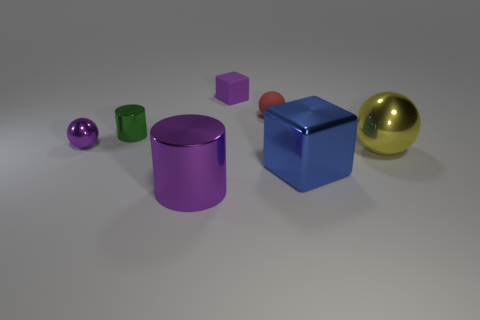How big is the blue cube?
Ensure brevity in your answer.  Large. There is a cube to the right of the small purple rubber thing; what is its size?
Provide a succinct answer. Large. What shape is the thing that is both left of the tiny purple cube and in front of the tiny purple metallic thing?
Offer a very short reply. Cylinder. What number of other things are the same shape as the large blue metal object?
Your answer should be compact. 1. What is the color of the metallic sphere that is the same size as the red matte thing?
Offer a terse response. Purple. What number of things are either large rubber cylinders or big yellow spheres?
Keep it short and to the point. 1. Are there any green metallic cylinders behind the red matte object?
Your response must be concise. No. Is there a large brown object that has the same material as the tiny green cylinder?
Ensure brevity in your answer.  No. The metallic cylinder that is the same color as the matte block is what size?
Offer a terse response. Large. How many cylinders are tiny shiny things or big purple things?
Provide a succinct answer. 2. 